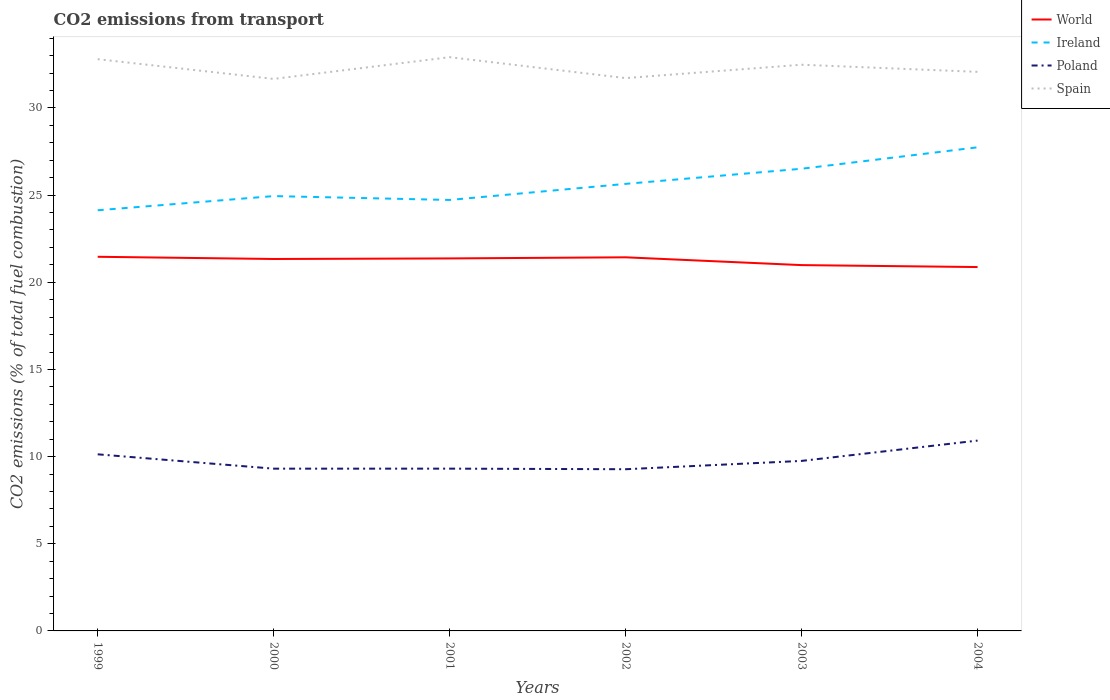How many different coloured lines are there?
Keep it short and to the point. 4. Across all years, what is the maximum total CO2 emitted in World?
Give a very brief answer. 20.87. In which year was the total CO2 emitted in Spain maximum?
Your answer should be very brief. 2000. What is the total total CO2 emitted in World in the graph?
Offer a very short reply. 0.11. What is the difference between the highest and the second highest total CO2 emitted in Poland?
Your answer should be very brief. 1.64. How many years are there in the graph?
Offer a terse response. 6. What is the difference between two consecutive major ticks on the Y-axis?
Offer a very short reply. 5. Where does the legend appear in the graph?
Your answer should be compact. Top right. What is the title of the graph?
Give a very brief answer. CO2 emissions from transport. Does "Spain" appear as one of the legend labels in the graph?
Your answer should be very brief. Yes. What is the label or title of the X-axis?
Offer a very short reply. Years. What is the label or title of the Y-axis?
Your answer should be very brief. CO2 emissions (% of total fuel combustion). What is the CO2 emissions (% of total fuel combustion) in World in 1999?
Provide a short and direct response. 21.46. What is the CO2 emissions (% of total fuel combustion) of Ireland in 1999?
Offer a terse response. 24.13. What is the CO2 emissions (% of total fuel combustion) in Poland in 1999?
Your answer should be very brief. 10.13. What is the CO2 emissions (% of total fuel combustion) in Spain in 1999?
Your answer should be compact. 32.8. What is the CO2 emissions (% of total fuel combustion) in World in 2000?
Offer a terse response. 21.34. What is the CO2 emissions (% of total fuel combustion) in Ireland in 2000?
Keep it short and to the point. 24.95. What is the CO2 emissions (% of total fuel combustion) of Poland in 2000?
Your response must be concise. 9.31. What is the CO2 emissions (% of total fuel combustion) in Spain in 2000?
Your response must be concise. 31.67. What is the CO2 emissions (% of total fuel combustion) of World in 2001?
Your response must be concise. 21.37. What is the CO2 emissions (% of total fuel combustion) of Ireland in 2001?
Ensure brevity in your answer.  24.72. What is the CO2 emissions (% of total fuel combustion) in Poland in 2001?
Provide a short and direct response. 9.31. What is the CO2 emissions (% of total fuel combustion) of Spain in 2001?
Provide a succinct answer. 32.91. What is the CO2 emissions (% of total fuel combustion) in World in 2002?
Your response must be concise. 21.43. What is the CO2 emissions (% of total fuel combustion) in Ireland in 2002?
Give a very brief answer. 25.65. What is the CO2 emissions (% of total fuel combustion) in Poland in 2002?
Provide a succinct answer. 9.28. What is the CO2 emissions (% of total fuel combustion) of Spain in 2002?
Offer a very short reply. 31.71. What is the CO2 emissions (% of total fuel combustion) of World in 2003?
Your answer should be compact. 20.99. What is the CO2 emissions (% of total fuel combustion) of Ireland in 2003?
Provide a short and direct response. 26.51. What is the CO2 emissions (% of total fuel combustion) of Poland in 2003?
Provide a short and direct response. 9.75. What is the CO2 emissions (% of total fuel combustion) in Spain in 2003?
Provide a short and direct response. 32.48. What is the CO2 emissions (% of total fuel combustion) of World in 2004?
Offer a very short reply. 20.87. What is the CO2 emissions (% of total fuel combustion) in Ireland in 2004?
Your answer should be compact. 27.74. What is the CO2 emissions (% of total fuel combustion) in Poland in 2004?
Keep it short and to the point. 10.92. What is the CO2 emissions (% of total fuel combustion) in Spain in 2004?
Give a very brief answer. 32.07. Across all years, what is the maximum CO2 emissions (% of total fuel combustion) in World?
Your response must be concise. 21.46. Across all years, what is the maximum CO2 emissions (% of total fuel combustion) of Ireland?
Offer a terse response. 27.74. Across all years, what is the maximum CO2 emissions (% of total fuel combustion) of Poland?
Provide a succinct answer. 10.92. Across all years, what is the maximum CO2 emissions (% of total fuel combustion) in Spain?
Offer a very short reply. 32.91. Across all years, what is the minimum CO2 emissions (% of total fuel combustion) of World?
Ensure brevity in your answer.  20.87. Across all years, what is the minimum CO2 emissions (% of total fuel combustion) in Ireland?
Provide a short and direct response. 24.13. Across all years, what is the minimum CO2 emissions (% of total fuel combustion) in Poland?
Offer a very short reply. 9.28. Across all years, what is the minimum CO2 emissions (% of total fuel combustion) in Spain?
Provide a short and direct response. 31.67. What is the total CO2 emissions (% of total fuel combustion) of World in the graph?
Make the answer very short. 127.46. What is the total CO2 emissions (% of total fuel combustion) in Ireland in the graph?
Keep it short and to the point. 153.7. What is the total CO2 emissions (% of total fuel combustion) in Poland in the graph?
Offer a terse response. 58.7. What is the total CO2 emissions (% of total fuel combustion) of Spain in the graph?
Offer a terse response. 193.65. What is the difference between the CO2 emissions (% of total fuel combustion) of World in 1999 and that in 2000?
Keep it short and to the point. 0.13. What is the difference between the CO2 emissions (% of total fuel combustion) in Ireland in 1999 and that in 2000?
Offer a terse response. -0.81. What is the difference between the CO2 emissions (% of total fuel combustion) in Poland in 1999 and that in 2000?
Your answer should be very brief. 0.82. What is the difference between the CO2 emissions (% of total fuel combustion) of Spain in 1999 and that in 2000?
Offer a very short reply. 1.13. What is the difference between the CO2 emissions (% of total fuel combustion) in World in 1999 and that in 2001?
Ensure brevity in your answer.  0.09. What is the difference between the CO2 emissions (% of total fuel combustion) of Ireland in 1999 and that in 2001?
Offer a very short reply. -0.59. What is the difference between the CO2 emissions (% of total fuel combustion) in Poland in 1999 and that in 2001?
Provide a short and direct response. 0.82. What is the difference between the CO2 emissions (% of total fuel combustion) of Spain in 1999 and that in 2001?
Ensure brevity in your answer.  -0.11. What is the difference between the CO2 emissions (% of total fuel combustion) of World in 1999 and that in 2002?
Offer a terse response. 0.03. What is the difference between the CO2 emissions (% of total fuel combustion) in Ireland in 1999 and that in 2002?
Offer a very short reply. -1.51. What is the difference between the CO2 emissions (% of total fuel combustion) in Poland in 1999 and that in 2002?
Your answer should be very brief. 0.86. What is the difference between the CO2 emissions (% of total fuel combustion) of Spain in 1999 and that in 2002?
Your answer should be compact. 1.08. What is the difference between the CO2 emissions (% of total fuel combustion) in World in 1999 and that in 2003?
Offer a terse response. 0.48. What is the difference between the CO2 emissions (% of total fuel combustion) of Ireland in 1999 and that in 2003?
Give a very brief answer. -2.38. What is the difference between the CO2 emissions (% of total fuel combustion) of Poland in 1999 and that in 2003?
Your response must be concise. 0.38. What is the difference between the CO2 emissions (% of total fuel combustion) in Spain in 1999 and that in 2003?
Your response must be concise. 0.32. What is the difference between the CO2 emissions (% of total fuel combustion) of World in 1999 and that in 2004?
Give a very brief answer. 0.59. What is the difference between the CO2 emissions (% of total fuel combustion) of Ireland in 1999 and that in 2004?
Offer a terse response. -3.61. What is the difference between the CO2 emissions (% of total fuel combustion) of Poland in 1999 and that in 2004?
Your answer should be very brief. -0.79. What is the difference between the CO2 emissions (% of total fuel combustion) in Spain in 1999 and that in 2004?
Your answer should be very brief. 0.73. What is the difference between the CO2 emissions (% of total fuel combustion) in World in 2000 and that in 2001?
Make the answer very short. -0.03. What is the difference between the CO2 emissions (% of total fuel combustion) of Ireland in 2000 and that in 2001?
Keep it short and to the point. 0.22. What is the difference between the CO2 emissions (% of total fuel combustion) of Poland in 2000 and that in 2001?
Give a very brief answer. -0. What is the difference between the CO2 emissions (% of total fuel combustion) of Spain in 2000 and that in 2001?
Ensure brevity in your answer.  -1.25. What is the difference between the CO2 emissions (% of total fuel combustion) of World in 2000 and that in 2002?
Your response must be concise. -0.1. What is the difference between the CO2 emissions (% of total fuel combustion) of Ireland in 2000 and that in 2002?
Provide a succinct answer. -0.7. What is the difference between the CO2 emissions (% of total fuel combustion) of Poland in 2000 and that in 2002?
Your response must be concise. 0.03. What is the difference between the CO2 emissions (% of total fuel combustion) of Spain in 2000 and that in 2002?
Give a very brief answer. -0.05. What is the difference between the CO2 emissions (% of total fuel combustion) of World in 2000 and that in 2003?
Provide a succinct answer. 0.35. What is the difference between the CO2 emissions (% of total fuel combustion) in Ireland in 2000 and that in 2003?
Your answer should be compact. -1.57. What is the difference between the CO2 emissions (% of total fuel combustion) in Poland in 2000 and that in 2003?
Offer a very short reply. -0.44. What is the difference between the CO2 emissions (% of total fuel combustion) of Spain in 2000 and that in 2003?
Provide a short and direct response. -0.81. What is the difference between the CO2 emissions (% of total fuel combustion) of World in 2000 and that in 2004?
Ensure brevity in your answer.  0.46. What is the difference between the CO2 emissions (% of total fuel combustion) of Ireland in 2000 and that in 2004?
Offer a very short reply. -2.8. What is the difference between the CO2 emissions (% of total fuel combustion) in Poland in 2000 and that in 2004?
Offer a terse response. -1.61. What is the difference between the CO2 emissions (% of total fuel combustion) in Spain in 2000 and that in 2004?
Your response must be concise. -0.41. What is the difference between the CO2 emissions (% of total fuel combustion) in World in 2001 and that in 2002?
Ensure brevity in your answer.  -0.06. What is the difference between the CO2 emissions (% of total fuel combustion) of Ireland in 2001 and that in 2002?
Give a very brief answer. -0.92. What is the difference between the CO2 emissions (% of total fuel combustion) in Poland in 2001 and that in 2002?
Offer a very short reply. 0.03. What is the difference between the CO2 emissions (% of total fuel combustion) in Spain in 2001 and that in 2002?
Your response must be concise. 1.2. What is the difference between the CO2 emissions (% of total fuel combustion) in World in 2001 and that in 2003?
Your answer should be compact. 0.38. What is the difference between the CO2 emissions (% of total fuel combustion) in Ireland in 2001 and that in 2003?
Your response must be concise. -1.79. What is the difference between the CO2 emissions (% of total fuel combustion) of Poland in 2001 and that in 2003?
Give a very brief answer. -0.44. What is the difference between the CO2 emissions (% of total fuel combustion) in Spain in 2001 and that in 2003?
Your answer should be very brief. 0.43. What is the difference between the CO2 emissions (% of total fuel combustion) in World in 2001 and that in 2004?
Your answer should be very brief. 0.49. What is the difference between the CO2 emissions (% of total fuel combustion) of Ireland in 2001 and that in 2004?
Your answer should be very brief. -3.02. What is the difference between the CO2 emissions (% of total fuel combustion) of Poland in 2001 and that in 2004?
Make the answer very short. -1.61. What is the difference between the CO2 emissions (% of total fuel combustion) in Spain in 2001 and that in 2004?
Your answer should be compact. 0.84. What is the difference between the CO2 emissions (% of total fuel combustion) of World in 2002 and that in 2003?
Your response must be concise. 0.45. What is the difference between the CO2 emissions (% of total fuel combustion) in Ireland in 2002 and that in 2003?
Offer a terse response. -0.87. What is the difference between the CO2 emissions (% of total fuel combustion) in Poland in 2002 and that in 2003?
Keep it short and to the point. -0.48. What is the difference between the CO2 emissions (% of total fuel combustion) in Spain in 2002 and that in 2003?
Keep it short and to the point. -0.77. What is the difference between the CO2 emissions (% of total fuel combustion) of World in 2002 and that in 2004?
Provide a short and direct response. 0.56. What is the difference between the CO2 emissions (% of total fuel combustion) in Ireland in 2002 and that in 2004?
Make the answer very short. -2.1. What is the difference between the CO2 emissions (% of total fuel combustion) of Poland in 2002 and that in 2004?
Make the answer very short. -1.64. What is the difference between the CO2 emissions (% of total fuel combustion) of Spain in 2002 and that in 2004?
Ensure brevity in your answer.  -0.36. What is the difference between the CO2 emissions (% of total fuel combustion) of World in 2003 and that in 2004?
Your answer should be compact. 0.11. What is the difference between the CO2 emissions (% of total fuel combustion) in Ireland in 2003 and that in 2004?
Your response must be concise. -1.23. What is the difference between the CO2 emissions (% of total fuel combustion) in Poland in 2003 and that in 2004?
Your response must be concise. -1.17. What is the difference between the CO2 emissions (% of total fuel combustion) of Spain in 2003 and that in 2004?
Provide a succinct answer. 0.41. What is the difference between the CO2 emissions (% of total fuel combustion) of World in 1999 and the CO2 emissions (% of total fuel combustion) of Ireland in 2000?
Keep it short and to the point. -3.48. What is the difference between the CO2 emissions (% of total fuel combustion) of World in 1999 and the CO2 emissions (% of total fuel combustion) of Poland in 2000?
Make the answer very short. 12.15. What is the difference between the CO2 emissions (% of total fuel combustion) in World in 1999 and the CO2 emissions (% of total fuel combustion) in Spain in 2000?
Provide a short and direct response. -10.2. What is the difference between the CO2 emissions (% of total fuel combustion) of Ireland in 1999 and the CO2 emissions (% of total fuel combustion) of Poland in 2000?
Ensure brevity in your answer.  14.82. What is the difference between the CO2 emissions (% of total fuel combustion) in Ireland in 1999 and the CO2 emissions (% of total fuel combustion) in Spain in 2000?
Your answer should be compact. -7.54. What is the difference between the CO2 emissions (% of total fuel combustion) in Poland in 1999 and the CO2 emissions (% of total fuel combustion) in Spain in 2000?
Offer a very short reply. -21.54. What is the difference between the CO2 emissions (% of total fuel combustion) of World in 1999 and the CO2 emissions (% of total fuel combustion) of Ireland in 2001?
Offer a very short reply. -3.26. What is the difference between the CO2 emissions (% of total fuel combustion) of World in 1999 and the CO2 emissions (% of total fuel combustion) of Poland in 2001?
Provide a succinct answer. 12.15. What is the difference between the CO2 emissions (% of total fuel combustion) of World in 1999 and the CO2 emissions (% of total fuel combustion) of Spain in 2001?
Give a very brief answer. -11.45. What is the difference between the CO2 emissions (% of total fuel combustion) of Ireland in 1999 and the CO2 emissions (% of total fuel combustion) of Poland in 2001?
Keep it short and to the point. 14.82. What is the difference between the CO2 emissions (% of total fuel combustion) of Ireland in 1999 and the CO2 emissions (% of total fuel combustion) of Spain in 2001?
Ensure brevity in your answer.  -8.78. What is the difference between the CO2 emissions (% of total fuel combustion) in Poland in 1999 and the CO2 emissions (% of total fuel combustion) in Spain in 2001?
Offer a very short reply. -22.78. What is the difference between the CO2 emissions (% of total fuel combustion) of World in 1999 and the CO2 emissions (% of total fuel combustion) of Ireland in 2002?
Your response must be concise. -4.18. What is the difference between the CO2 emissions (% of total fuel combustion) in World in 1999 and the CO2 emissions (% of total fuel combustion) in Poland in 2002?
Your answer should be compact. 12.19. What is the difference between the CO2 emissions (% of total fuel combustion) of World in 1999 and the CO2 emissions (% of total fuel combustion) of Spain in 2002?
Give a very brief answer. -10.25. What is the difference between the CO2 emissions (% of total fuel combustion) in Ireland in 1999 and the CO2 emissions (% of total fuel combustion) in Poland in 2002?
Give a very brief answer. 14.86. What is the difference between the CO2 emissions (% of total fuel combustion) of Ireland in 1999 and the CO2 emissions (% of total fuel combustion) of Spain in 2002?
Make the answer very short. -7.58. What is the difference between the CO2 emissions (% of total fuel combustion) in Poland in 1999 and the CO2 emissions (% of total fuel combustion) in Spain in 2002?
Your answer should be very brief. -21.58. What is the difference between the CO2 emissions (% of total fuel combustion) of World in 1999 and the CO2 emissions (% of total fuel combustion) of Ireland in 2003?
Provide a succinct answer. -5.05. What is the difference between the CO2 emissions (% of total fuel combustion) in World in 1999 and the CO2 emissions (% of total fuel combustion) in Poland in 2003?
Offer a very short reply. 11.71. What is the difference between the CO2 emissions (% of total fuel combustion) in World in 1999 and the CO2 emissions (% of total fuel combustion) in Spain in 2003?
Provide a short and direct response. -11.02. What is the difference between the CO2 emissions (% of total fuel combustion) in Ireland in 1999 and the CO2 emissions (% of total fuel combustion) in Poland in 2003?
Your response must be concise. 14.38. What is the difference between the CO2 emissions (% of total fuel combustion) in Ireland in 1999 and the CO2 emissions (% of total fuel combustion) in Spain in 2003?
Provide a short and direct response. -8.35. What is the difference between the CO2 emissions (% of total fuel combustion) in Poland in 1999 and the CO2 emissions (% of total fuel combustion) in Spain in 2003?
Give a very brief answer. -22.35. What is the difference between the CO2 emissions (% of total fuel combustion) of World in 1999 and the CO2 emissions (% of total fuel combustion) of Ireland in 2004?
Offer a very short reply. -6.28. What is the difference between the CO2 emissions (% of total fuel combustion) of World in 1999 and the CO2 emissions (% of total fuel combustion) of Poland in 2004?
Your answer should be very brief. 10.54. What is the difference between the CO2 emissions (% of total fuel combustion) in World in 1999 and the CO2 emissions (% of total fuel combustion) in Spain in 2004?
Ensure brevity in your answer.  -10.61. What is the difference between the CO2 emissions (% of total fuel combustion) of Ireland in 1999 and the CO2 emissions (% of total fuel combustion) of Poland in 2004?
Offer a very short reply. 13.21. What is the difference between the CO2 emissions (% of total fuel combustion) in Ireland in 1999 and the CO2 emissions (% of total fuel combustion) in Spain in 2004?
Ensure brevity in your answer.  -7.94. What is the difference between the CO2 emissions (% of total fuel combustion) in Poland in 1999 and the CO2 emissions (% of total fuel combustion) in Spain in 2004?
Offer a very short reply. -21.94. What is the difference between the CO2 emissions (% of total fuel combustion) of World in 2000 and the CO2 emissions (% of total fuel combustion) of Ireland in 2001?
Give a very brief answer. -3.39. What is the difference between the CO2 emissions (% of total fuel combustion) in World in 2000 and the CO2 emissions (% of total fuel combustion) in Poland in 2001?
Offer a terse response. 12.03. What is the difference between the CO2 emissions (% of total fuel combustion) of World in 2000 and the CO2 emissions (% of total fuel combustion) of Spain in 2001?
Offer a terse response. -11.58. What is the difference between the CO2 emissions (% of total fuel combustion) of Ireland in 2000 and the CO2 emissions (% of total fuel combustion) of Poland in 2001?
Offer a terse response. 15.64. What is the difference between the CO2 emissions (% of total fuel combustion) in Ireland in 2000 and the CO2 emissions (% of total fuel combustion) in Spain in 2001?
Provide a succinct answer. -7.97. What is the difference between the CO2 emissions (% of total fuel combustion) in Poland in 2000 and the CO2 emissions (% of total fuel combustion) in Spain in 2001?
Provide a succinct answer. -23.61. What is the difference between the CO2 emissions (% of total fuel combustion) in World in 2000 and the CO2 emissions (% of total fuel combustion) in Ireland in 2002?
Offer a terse response. -4.31. What is the difference between the CO2 emissions (% of total fuel combustion) in World in 2000 and the CO2 emissions (% of total fuel combustion) in Poland in 2002?
Provide a succinct answer. 12.06. What is the difference between the CO2 emissions (% of total fuel combustion) in World in 2000 and the CO2 emissions (% of total fuel combustion) in Spain in 2002?
Give a very brief answer. -10.38. What is the difference between the CO2 emissions (% of total fuel combustion) of Ireland in 2000 and the CO2 emissions (% of total fuel combustion) of Poland in 2002?
Ensure brevity in your answer.  15.67. What is the difference between the CO2 emissions (% of total fuel combustion) of Ireland in 2000 and the CO2 emissions (% of total fuel combustion) of Spain in 2002?
Ensure brevity in your answer.  -6.77. What is the difference between the CO2 emissions (% of total fuel combustion) in Poland in 2000 and the CO2 emissions (% of total fuel combustion) in Spain in 2002?
Offer a terse response. -22.41. What is the difference between the CO2 emissions (% of total fuel combustion) in World in 2000 and the CO2 emissions (% of total fuel combustion) in Ireland in 2003?
Offer a terse response. -5.18. What is the difference between the CO2 emissions (% of total fuel combustion) of World in 2000 and the CO2 emissions (% of total fuel combustion) of Poland in 2003?
Offer a very short reply. 11.58. What is the difference between the CO2 emissions (% of total fuel combustion) of World in 2000 and the CO2 emissions (% of total fuel combustion) of Spain in 2003?
Give a very brief answer. -11.14. What is the difference between the CO2 emissions (% of total fuel combustion) of Ireland in 2000 and the CO2 emissions (% of total fuel combustion) of Poland in 2003?
Your response must be concise. 15.19. What is the difference between the CO2 emissions (% of total fuel combustion) in Ireland in 2000 and the CO2 emissions (% of total fuel combustion) in Spain in 2003?
Offer a very short reply. -7.54. What is the difference between the CO2 emissions (% of total fuel combustion) of Poland in 2000 and the CO2 emissions (% of total fuel combustion) of Spain in 2003?
Ensure brevity in your answer.  -23.17. What is the difference between the CO2 emissions (% of total fuel combustion) in World in 2000 and the CO2 emissions (% of total fuel combustion) in Ireland in 2004?
Keep it short and to the point. -6.41. What is the difference between the CO2 emissions (% of total fuel combustion) of World in 2000 and the CO2 emissions (% of total fuel combustion) of Poland in 2004?
Make the answer very short. 10.42. What is the difference between the CO2 emissions (% of total fuel combustion) of World in 2000 and the CO2 emissions (% of total fuel combustion) of Spain in 2004?
Offer a terse response. -10.74. What is the difference between the CO2 emissions (% of total fuel combustion) of Ireland in 2000 and the CO2 emissions (% of total fuel combustion) of Poland in 2004?
Offer a terse response. 14.03. What is the difference between the CO2 emissions (% of total fuel combustion) of Ireland in 2000 and the CO2 emissions (% of total fuel combustion) of Spain in 2004?
Offer a terse response. -7.13. What is the difference between the CO2 emissions (% of total fuel combustion) in Poland in 2000 and the CO2 emissions (% of total fuel combustion) in Spain in 2004?
Your response must be concise. -22.76. What is the difference between the CO2 emissions (% of total fuel combustion) of World in 2001 and the CO2 emissions (% of total fuel combustion) of Ireland in 2002?
Provide a short and direct response. -4.28. What is the difference between the CO2 emissions (% of total fuel combustion) in World in 2001 and the CO2 emissions (% of total fuel combustion) in Poland in 2002?
Offer a terse response. 12.09. What is the difference between the CO2 emissions (% of total fuel combustion) in World in 2001 and the CO2 emissions (% of total fuel combustion) in Spain in 2002?
Offer a very short reply. -10.35. What is the difference between the CO2 emissions (% of total fuel combustion) of Ireland in 2001 and the CO2 emissions (% of total fuel combustion) of Poland in 2002?
Ensure brevity in your answer.  15.45. What is the difference between the CO2 emissions (% of total fuel combustion) of Ireland in 2001 and the CO2 emissions (% of total fuel combustion) of Spain in 2002?
Offer a terse response. -6.99. What is the difference between the CO2 emissions (% of total fuel combustion) in Poland in 2001 and the CO2 emissions (% of total fuel combustion) in Spain in 2002?
Make the answer very short. -22.41. What is the difference between the CO2 emissions (% of total fuel combustion) in World in 2001 and the CO2 emissions (% of total fuel combustion) in Ireland in 2003?
Provide a succinct answer. -5.14. What is the difference between the CO2 emissions (% of total fuel combustion) of World in 2001 and the CO2 emissions (% of total fuel combustion) of Poland in 2003?
Offer a terse response. 11.62. What is the difference between the CO2 emissions (% of total fuel combustion) of World in 2001 and the CO2 emissions (% of total fuel combustion) of Spain in 2003?
Offer a very short reply. -11.11. What is the difference between the CO2 emissions (% of total fuel combustion) in Ireland in 2001 and the CO2 emissions (% of total fuel combustion) in Poland in 2003?
Provide a succinct answer. 14.97. What is the difference between the CO2 emissions (% of total fuel combustion) in Ireland in 2001 and the CO2 emissions (% of total fuel combustion) in Spain in 2003?
Your answer should be very brief. -7.76. What is the difference between the CO2 emissions (% of total fuel combustion) of Poland in 2001 and the CO2 emissions (% of total fuel combustion) of Spain in 2003?
Ensure brevity in your answer.  -23.17. What is the difference between the CO2 emissions (% of total fuel combustion) in World in 2001 and the CO2 emissions (% of total fuel combustion) in Ireland in 2004?
Provide a succinct answer. -6.37. What is the difference between the CO2 emissions (% of total fuel combustion) of World in 2001 and the CO2 emissions (% of total fuel combustion) of Poland in 2004?
Provide a short and direct response. 10.45. What is the difference between the CO2 emissions (% of total fuel combustion) in World in 2001 and the CO2 emissions (% of total fuel combustion) in Spain in 2004?
Your answer should be very brief. -10.7. What is the difference between the CO2 emissions (% of total fuel combustion) of Ireland in 2001 and the CO2 emissions (% of total fuel combustion) of Poland in 2004?
Your answer should be very brief. 13.8. What is the difference between the CO2 emissions (% of total fuel combustion) of Ireland in 2001 and the CO2 emissions (% of total fuel combustion) of Spain in 2004?
Provide a succinct answer. -7.35. What is the difference between the CO2 emissions (% of total fuel combustion) in Poland in 2001 and the CO2 emissions (% of total fuel combustion) in Spain in 2004?
Provide a succinct answer. -22.76. What is the difference between the CO2 emissions (% of total fuel combustion) of World in 2002 and the CO2 emissions (% of total fuel combustion) of Ireland in 2003?
Provide a succinct answer. -5.08. What is the difference between the CO2 emissions (% of total fuel combustion) of World in 2002 and the CO2 emissions (% of total fuel combustion) of Poland in 2003?
Provide a succinct answer. 11.68. What is the difference between the CO2 emissions (% of total fuel combustion) in World in 2002 and the CO2 emissions (% of total fuel combustion) in Spain in 2003?
Your response must be concise. -11.05. What is the difference between the CO2 emissions (% of total fuel combustion) of Ireland in 2002 and the CO2 emissions (% of total fuel combustion) of Poland in 2003?
Offer a very short reply. 15.89. What is the difference between the CO2 emissions (% of total fuel combustion) in Ireland in 2002 and the CO2 emissions (% of total fuel combustion) in Spain in 2003?
Provide a short and direct response. -6.83. What is the difference between the CO2 emissions (% of total fuel combustion) of Poland in 2002 and the CO2 emissions (% of total fuel combustion) of Spain in 2003?
Provide a short and direct response. -23.2. What is the difference between the CO2 emissions (% of total fuel combustion) in World in 2002 and the CO2 emissions (% of total fuel combustion) in Ireland in 2004?
Make the answer very short. -6.31. What is the difference between the CO2 emissions (% of total fuel combustion) of World in 2002 and the CO2 emissions (% of total fuel combustion) of Poland in 2004?
Provide a short and direct response. 10.51. What is the difference between the CO2 emissions (% of total fuel combustion) in World in 2002 and the CO2 emissions (% of total fuel combustion) in Spain in 2004?
Give a very brief answer. -10.64. What is the difference between the CO2 emissions (% of total fuel combustion) of Ireland in 2002 and the CO2 emissions (% of total fuel combustion) of Poland in 2004?
Provide a succinct answer. 14.73. What is the difference between the CO2 emissions (% of total fuel combustion) of Ireland in 2002 and the CO2 emissions (% of total fuel combustion) of Spain in 2004?
Provide a short and direct response. -6.43. What is the difference between the CO2 emissions (% of total fuel combustion) of Poland in 2002 and the CO2 emissions (% of total fuel combustion) of Spain in 2004?
Provide a succinct answer. -22.8. What is the difference between the CO2 emissions (% of total fuel combustion) of World in 2003 and the CO2 emissions (% of total fuel combustion) of Ireland in 2004?
Provide a short and direct response. -6.76. What is the difference between the CO2 emissions (% of total fuel combustion) in World in 2003 and the CO2 emissions (% of total fuel combustion) in Poland in 2004?
Your response must be concise. 10.07. What is the difference between the CO2 emissions (% of total fuel combustion) in World in 2003 and the CO2 emissions (% of total fuel combustion) in Spain in 2004?
Keep it short and to the point. -11.09. What is the difference between the CO2 emissions (% of total fuel combustion) in Ireland in 2003 and the CO2 emissions (% of total fuel combustion) in Poland in 2004?
Your answer should be very brief. 15.59. What is the difference between the CO2 emissions (% of total fuel combustion) in Ireland in 2003 and the CO2 emissions (% of total fuel combustion) in Spain in 2004?
Keep it short and to the point. -5.56. What is the difference between the CO2 emissions (% of total fuel combustion) in Poland in 2003 and the CO2 emissions (% of total fuel combustion) in Spain in 2004?
Your answer should be compact. -22.32. What is the average CO2 emissions (% of total fuel combustion) of World per year?
Offer a very short reply. 21.24. What is the average CO2 emissions (% of total fuel combustion) of Ireland per year?
Give a very brief answer. 25.62. What is the average CO2 emissions (% of total fuel combustion) of Poland per year?
Your response must be concise. 9.78. What is the average CO2 emissions (% of total fuel combustion) of Spain per year?
Provide a short and direct response. 32.27. In the year 1999, what is the difference between the CO2 emissions (% of total fuel combustion) in World and CO2 emissions (% of total fuel combustion) in Ireland?
Make the answer very short. -2.67. In the year 1999, what is the difference between the CO2 emissions (% of total fuel combustion) in World and CO2 emissions (% of total fuel combustion) in Poland?
Offer a terse response. 11.33. In the year 1999, what is the difference between the CO2 emissions (% of total fuel combustion) in World and CO2 emissions (% of total fuel combustion) in Spain?
Your answer should be very brief. -11.34. In the year 1999, what is the difference between the CO2 emissions (% of total fuel combustion) in Ireland and CO2 emissions (% of total fuel combustion) in Poland?
Provide a short and direct response. 14. In the year 1999, what is the difference between the CO2 emissions (% of total fuel combustion) in Ireland and CO2 emissions (% of total fuel combustion) in Spain?
Provide a succinct answer. -8.67. In the year 1999, what is the difference between the CO2 emissions (% of total fuel combustion) in Poland and CO2 emissions (% of total fuel combustion) in Spain?
Make the answer very short. -22.67. In the year 2000, what is the difference between the CO2 emissions (% of total fuel combustion) of World and CO2 emissions (% of total fuel combustion) of Ireland?
Your answer should be very brief. -3.61. In the year 2000, what is the difference between the CO2 emissions (% of total fuel combustion) in World and CO2 emissions (% of total fuel combustion) in Poland?
Keep it short and to the point. 12.03. In the year 2000, what is the difference between the CO2 emissions (% of total fuel combustion) of World and CO2 emissions (% of total fuel combustion) of Spain?
Keep it short and to the point. -10.33. In the year 2000, what is the difference between the CO2 emissions (% of total fuel combustion) in Ireland and CO2 emissions (% of total fuel combustion) in Poland?
Your answer should be very brief. 15.64. In the year 2000, what is the difference between the CO2 emissions (% of total fuel combustion) of Ireland and CO2 emissions (% of total fuel combustion) of Spain?
Offer a terse response. -6.72. In the year 2000, what is the difference between the CO2 emissions (% of total fuel combustion) of Poland and CO2 emissions (% of total fuel combustion) of Spain?
Provide a short and direct response. -22.36. In the year 2001, what is the difference between the CO2 emissions (% of total fuel combustion) of World and CO2 emissions (% of total fuel combustion) of Ireland?
Keep it short and to the point. -3.35. In the year 2001, what is the difference between the CO2 emissions (% of total fuel combustion) of World and CO2 emissions (% of total fuel combustion) of Poland?
Your response must be concise. 12.06. In the year 2001, what is the difference between the CO2 emissions (% of total fuel combustion) in World and CO2 emissions (% of total fuel combustion) in Spain?
Offer a very short reply. -11.54. In the year 2001, what is the difference between the CO2 emissions (% of total fuel combustion) of Ireland and CO2 emissions (% of total fuel combustion) of Poland?
Give a very brief answer. 15.41. In the year 2001, what is the difference between the CO2 emissions (% of total fuel combustion) in Ireland and CO2 emissions (% of total fuel combustion) in Spain?
Offer a terse response. -8.19. In the year 2001, what is the difference between the CO2 emissions (% of total fuel combustion) of Poland and CO2 emissions (% of total fuel combustion) of Spain?
Your answer should be very brief. -23.6. In the year 2002, what is the difference between the CO2 emissions (% of total fuel combustion) in World and CO2 emissions (% of total fuel combustion) in Ireland?
Offer a very short reply. -4.21. In the year 2002, what is the difference between the CO2 emissions (% of total fuel combustion) of World and CO2 emissions (% of total fuel combustion) of Poland?
Provide a succinct answer. 12.16. In the year 2002, what is the difference between the CO2 emissions (% of total fuel combustion) in World and CO2 emissions (% of total fuel combustion) in Spain?
Offer a very short reply. -10.28. In the year 2002, what is the difference between the CO2 emissions (% of total fuel combustion) in Ireland and CO2 emissions (% of total fuel combustion) in Poland?
Make the answer very short. 16.37. In the year 2002, what is the difference between the CO2 emissions (% of total fuel combustion) in Ireland and CO2 emissions (% of total fuel combustion) in Spain?
Provide a short and direct response. -6.07. In the year 2002, what is the difference between the CO2 emissions (% of total fuel combustion) in Poland and CO2 emissions (% of total fuel combustion) in Spain?
Offer a very short reply. -22.44. In the year 2003, what is the difference between the CO2 emissions (% of total fuel combustion) in World and CO2 emissions (% of total fuel combustion) in Ireland?
Offer a very short reply. -5.53. In the year 2003, what is the difference between the CO2 emissions (% of total fuel combustion) in World and CO2 emissions (% of total fuel combustion) in Poland?
Offer a very short reply. 11.23. In the year 2003, what is the difference between the CO2 emissions (% of total fuel combustion) of World and CO2 emissions (% of total fuel combustion) of Spain?
Provide a short and direct response. -11.49. In the year 2003, what is the difference between the CO2 emissions (% of total fuel combustion) of Ireland and CO2 emissions (% of total fuel combustion) of Poland?
Make the answer very short. 16.76. In the year 2003, what is the difference between the CO2 emissions (% of total fuel combustion) of Ireland and CO2 emissions (% of total fuel combustion) of Spain?
Offer a very short reply. -5.97. In the year 2003, what is the difference between the CO2 emissions (% of total fuel combustion) in Poland and CO2 emissions (% of total fuel combustion) in Spain?
Make the answer very short. -22.73. In the year 2004, what is the difference between the CO2 emissions (% of total fuel combustion) in World and CO2 emissions (% of total fuel combustion) in Ireland?
Make the answer very short. -6.87. In the year 2004, what is the difference between the CO2 emissions (% of total fuel combustion) in World and CO2 emissions (% of total fuel combustion) in Poland?
Provide a succinct answer. 9.96. In the year 2004, what is the difference between the CO2 emissions (% of total fuel combustion) in World and CO2 emissions (% of total fuel combustion) in Spain?
Give a very brief answer. -11.2. In the year 2004, what is the difference between the CO2 emissions (% of total fuel combustion) of Ireland and CO2 emissions (% of total fuel combustion) of Poland?
Give a very brief answer. 16.82. In the year 2004, what is the difference between the CO2 emissions (% of total fuel combustion) of Ireland and CO2 emissions (% of total fuel combustion) of Spain?
Your answer should be very brief. -4.33. In the year 2004, what is the difference between the CO2 emissions (% of total fuel combustion) in Poland and CO2 emissions (% of total fuel combustion) in Spain?
Make the answer very short. -21.15. What is the ratio of the CO2 emissions (% of total fuel combustion) of World in 1999 to that in 2000?
Give a very brief answer. 1.01. What is the ratio of the CO2 emissions (% of total fuel combustion) of Ireland in 1999 to that in 2000?
Keep it short and to the point. 0.97. What is the ratio of the CO2 emissions (% of total fuel combustion) of Poland in 1999 to that in 2000?
Ensure brevity in your answer.  1.09. What is the ratio of the CO2 emissions (% of total fuel combustion) of Spain in 1999 to that in 2000?
Your answer should be very brief. 1.04. What is the ratio of the CO2 emissions (% of total fuel combustion) of World in 1999 to that in 2001?
Make the answer very short. 1. What is the ratio of the CO2 emissions (% of total fuel combustion) in Ireland in 1999 to that in 2001?
Make the answer very short. 0.98. What is the ratio of the CO2 emissions (% of total fuel combustion) of Poland in 1999 to that in 2001?
Keep it short and to the point. 1.09. What is the ratio of the CO2 emissions (% of total fuel combustion) of World in 1999 to that in 2002?
Provide a short and direct response. 1. What is the ratio of the CO2 emissions (% of total fuel combustion) of Ireland in 1999 to that in 2002?
Make the answer very short. 0.94. What is the ratio of the CO2 emissions (% of total fuel combustion) in Poland in 1999 to that in 2002?
Ensure brevity in your answer.  1.09. What is the ratio of the CO2 emissions (% of total fuel combustion) of Spain in 1999 to that in 2002?
Provide a short and direct response. 1.03. What is the ratio of the CO2 emissions (% of total fuel combustion) in World in 1999 to that in 2003?
Offer a very short reply. 1.02. What is the ratio of the CO2 emissions (% of total fuel combustion) of Ireland in 1999 to that in 2003?
Your answer should be compact. 0.91. What is the ratio of the CO2 emissions (% of total fuel combustion) of Poland in 1999 to that in 2003?
Offer a terse response. 1.04. What is the ratio of the CO2 emissions (% of total fuel combustion) of Spain in 1999 to that in 2003?
Keep it short and to the point. 1.01. What is the ratio of the CO2 emissions (% of total fuel combustion) in World in 1999 to that in 2004?
Offer a very short reply. 1.03. What is the ratio of the CO2 emissions (% of total fuel combustion) in Ireland in 1999 to that in 2004?
Your response must be concise. 0.87. What is the ratio of the CO2 emissions (% of total fuel combustion) of Poland in 1999 to that in 2004?
Provide a succinct answer. 0.93. What is the ratio of the CO2 emissions (% of total fuel combustion) in Spain in 1999 to that in 2004?
Keep it short and to the point. 1.02. What is the ratio of the CO2 emissions (% of total fuel combustion) in Spain in 2000 to that in 2001?
Provide a succinct answer. 0.96. What is the ratio of the CO2 emissions (% of total fuel combustion) in World in 2000 to that in 2002?
Keep it short and to the point. 1. What is the ratio of the CO2 emissions (% of total fuel combustion) in Ireland in 2000 to that in 2002?
Keep it short and to the point. 0.97. What is the ratio of the CO2 emissions (% of total fuel combustion) of World in 2000 to that in 2003?
Your response must be concise. 1.02. What is the ratio of the CO2 emissions (% of total fuel combustion) of Ireland in 2000 to that in 2003?
Your answer should be compact. 0.94. What is the ratio of the CO2 emissions (% of total fuel combustion) in Poland in 2000 to that in 2003?
Make the answer very short. 0.95. What is the ratio of the CO2 emissions (% of total fuel combustion) of Spain in 2000 to that in 2003?
Your answer should be compact. 0.97. What is the ratio of the CO2 emissions (% of total fuel combustion) in World in 2000 to that in 2004?
Your answer should be very brief. 1.02. What is the ratio of the CO2 emissions (% of total fuel combustion) in Ireland in 2000 to that in 2004?
Keep it short and to the point. 0.9. What is the ratio of the CO2 emissions (% of total fuel combustion) of Poland in 2000 to that in 2004?
Make the answer very short. 0.85. What is the ratio of the CO2 emissions (% of total fuel combustion) of Spain in 2000 to that in 2004?
Offer a terse response. 0.99. What is the ratio of the CO2 emissions (% of total fuel combustion) in World in 2001 to that in 2002?
Keep it short and to the point. 1. What is the ratio of the CO2 emissions (% of total fuel combustion) in Ireland in 2001 to that in 2002?
Offer a terse response. 0.96. What is the ratio of the CO2 emissions (% of total fuel combustion) in Poland in 2001 to that in 2002?
Provide a short and direct response. 1. What is the ratio of the CO2 emissions (% of total fuel combustion) of Spain in 2001 to that in 2002?
Offer a terse response. 1.04. What is the ratio of the CO2 emissions (% of total fuel combustion) of World in 2001 to that in 2003?
Give a very brief answer. 1.02. What is the ratio of the CO2 emissions (% of total fuel combustion) in Ireland in 2001 to that in 2003?
Your response must be concise. 0.93. What is the ratio of the CO2 emissions (% of total fuel combustion) of Poland in 2001 to that in 2003?
Your answer should be very brief. 0.95. What is the ratio of the CO2 emissions (% of total fuel combustion) in Spain in 2001 to that in 2003?
Your answer should be compact. 1.01. What is the ratio of the CO2 emissions (% of total fuel combustion) of World in 2001 to that in 2004?
Offer a terse response. 1.02. What is the ratio of the CO2 emissions (% of total fuel combustion) of Ireland in 2001 to that in 2004?
Offer a very short reply. 0.89. What is the ratio of the CO2 emissions (% of total fuel combustion) of Poland in 2001 to that in 2004?
Make the answer very short. 0.85. What is the ratio of the CO2 emissions (% of total fuel combustion) in Spain in 2001 to that in 2004?
Give a very brief answer. 1.03. What is the ratio of the CO2 emissions (% of total fuel combustion) in World in 2002 to that in 2003?
Ensure brevity in your answer.  1.02. What is the ratio of the CO2 emissions (% of total fuel combustion) of Ireland in 2002 to that in 2003?
Provide a short and direct response. 0.97. What is the ratio of the CO2 emissions (% of total fuel combustion) in Poland in 2002 to that in 2003?
Your response must be concise. 0.95. What is the ratio of the CO2 emissions (% of total fuel combustion) of Spain in 2002 to that in 2003?
Give a very brief answer. 0.98. What is the ratio of the CO2 emissions (% of total fuel combustion) in World in 2002 to that in 2004?
Your answer should be compact. 1.03. What is the ratio of the CO2 emissions (% of total fuel combustion) in Ireland in 2002 to that in 2004?
Give a very brief answer. 0.92. What is the ratio of the CO2 emissions (% of total fuel combustion) in Poland in 2002 to that in 2004?
Give a very brief answer. 0.85. What is the ratio of the CO2 emissions (% of total fuel combustion) in Spain in 2002 to that in 2004?
Ensure brevity in your answer.  0.99. What is the ratio of the CO2 emissions (% of total fuel combustion) of World in 2003 to that in 2004?
Give a very brief answer. 1.01. What is the ratio of the CO2 emissions (% of total fuel combustion) in Ireland in 2003 to that in 2004?
Your response must be concise. 0.96. What is the ratio of the CO2 emissions (% of total fuel combustion) in Poland in 2003 to that in 2004?
Give a very brief answer. 0.89. What is the ratio of the CO2 emissions (% of total fuel combustion) in Spain in 2003 to that in 2004?
Keep it short and to the point. 1.01. What is the difference between the highest and the second highest CO2 emissions (% of total fuel combustion) of World?
Make the answer very short. 0.03. What is the difference between the highest and the second highest CO2 emissions (% of total fuel combustion) in Ireland?
Offer a terse response. 1.23. What is the difference between the highest and the second highest CO2 emissions (% of total fuel combustion) of Poland?
Offer a very short reply. 0.79. What is the difference between the highest and the second highest CO2 emissions (% of total fuel combustion) in Spain?
Keep it short and to the point. 0.11. What is the difference between the highest and the lowest CO2 emissions (% of total fuel combustion) in World?
Your answer should be very brief. 0.59. What is the difference between the highest and the lowest CO2 emissions (% of total fuel combustion) of Ireland?
Your answer should be very brief. 3.61. What is the difference between the highest and the lowest CO2 emissions (% of total fuel combustion) in Poland?
Provide a short and direct response. 1.64. What is the difference between the highest and the lowest CO2 emissions (% of total fuel combustion) of Spain?
Give a very brief answer. 1.25. 